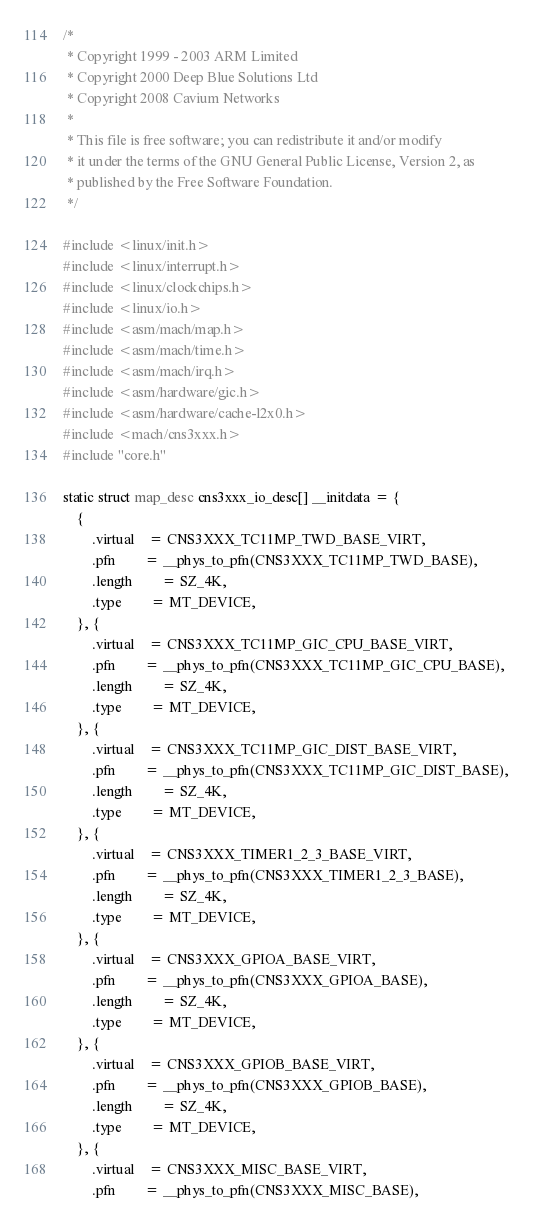Convert code to text. <code><loc_0><loc_0><loc_500><loc_500><_C_>/*
 * Copyright 1999 - 2003 ARM Limited
 * Copyright 2000 Deep Blue Solutions Ltd
 * Copyright 2008 Cavium Networks
 *
 * This file is free software; you can redistribute it and/or modify
 * it under the terms of the GNU General Public License, Version 2, as
 * published by the Free Software Foundation.
 */

#include <linux/init.h>
#include <linux/interrupt.h>
#include <linux/clockchips.h>
#include <linux/io.h>
#include <asm/mach/map.h>
#include <asm/mach/time.h>
#include <asm/mach/irq.h>
#include <asm/hardware/gic.h>
#include <asm/hardware/cache-l2x0.h>
#include <mach/cns3xxx.h>
#include "core.h"

static struct map_desc cns3xxx_io_desc[] __initdata = {
	{
		.virtual	= CNS3XXX_TC11MP_TWD_BASE_VIRT,
		.pfn		= __phys_to_pfn(CNS3XXX_TC11MP_TWD_BASE),
		.length		= SZ_4K,
		.type		= MT_DEVICE,
	}, {
		.virtual	= CNS3XXX_TC11MP_GIC_CPU_BASE_VIRT,
		.pfn		= __phys_to_pfn(CNS3XXX_TC11MP_GIC_CPU_BASE),
		.length		= SZ_4K,
		.type		= MT_DEVICE,
	}, {
		.virtual	= CNS3XXX_TC11MP_GIC_DIST_BASE_VIRT,
		.pfn		= __phys_to_pfn(CNS3XXX_TC11MP_GIC_DIST_BASE),
		.length		= SZ_4K,
		.type		= MT_DEVICE,
	}, {
		.virtual	= CNS3XXX_TIMER1_2_3_BASE_VIRT,
		.pfn		= __phys_to_pfn(CNS3XXX_TIMER1_2_3_BASE),
		.length		= SZ_4K,
		.type		= MT_DEVICE,
	}, {
		.virtual	= CNS3XXX_GPIOA_BASE_VIRT,
		.pfn		= __phys_to_pfn(CNS3XXX_GPIOA_BASE),
		.length		= SZ_4K,
		.type		= MT_DEVICE,
	}, {
		.virtual	= CNS3XXX_GPIOB_BASE_VIRT,
		.pfn		= __phys_to_pfn(CNS3XXX_GPIOB_BASE),
		.length		= SZ_4K,
		.type		= MT_DEVICE,
	}, {
		.virtual	= CNS3XXX_MISC_BASE_VIRT,
		.pfn		= __phys_to_pfn(CNS3XXX_MISC_BASE),</code> 